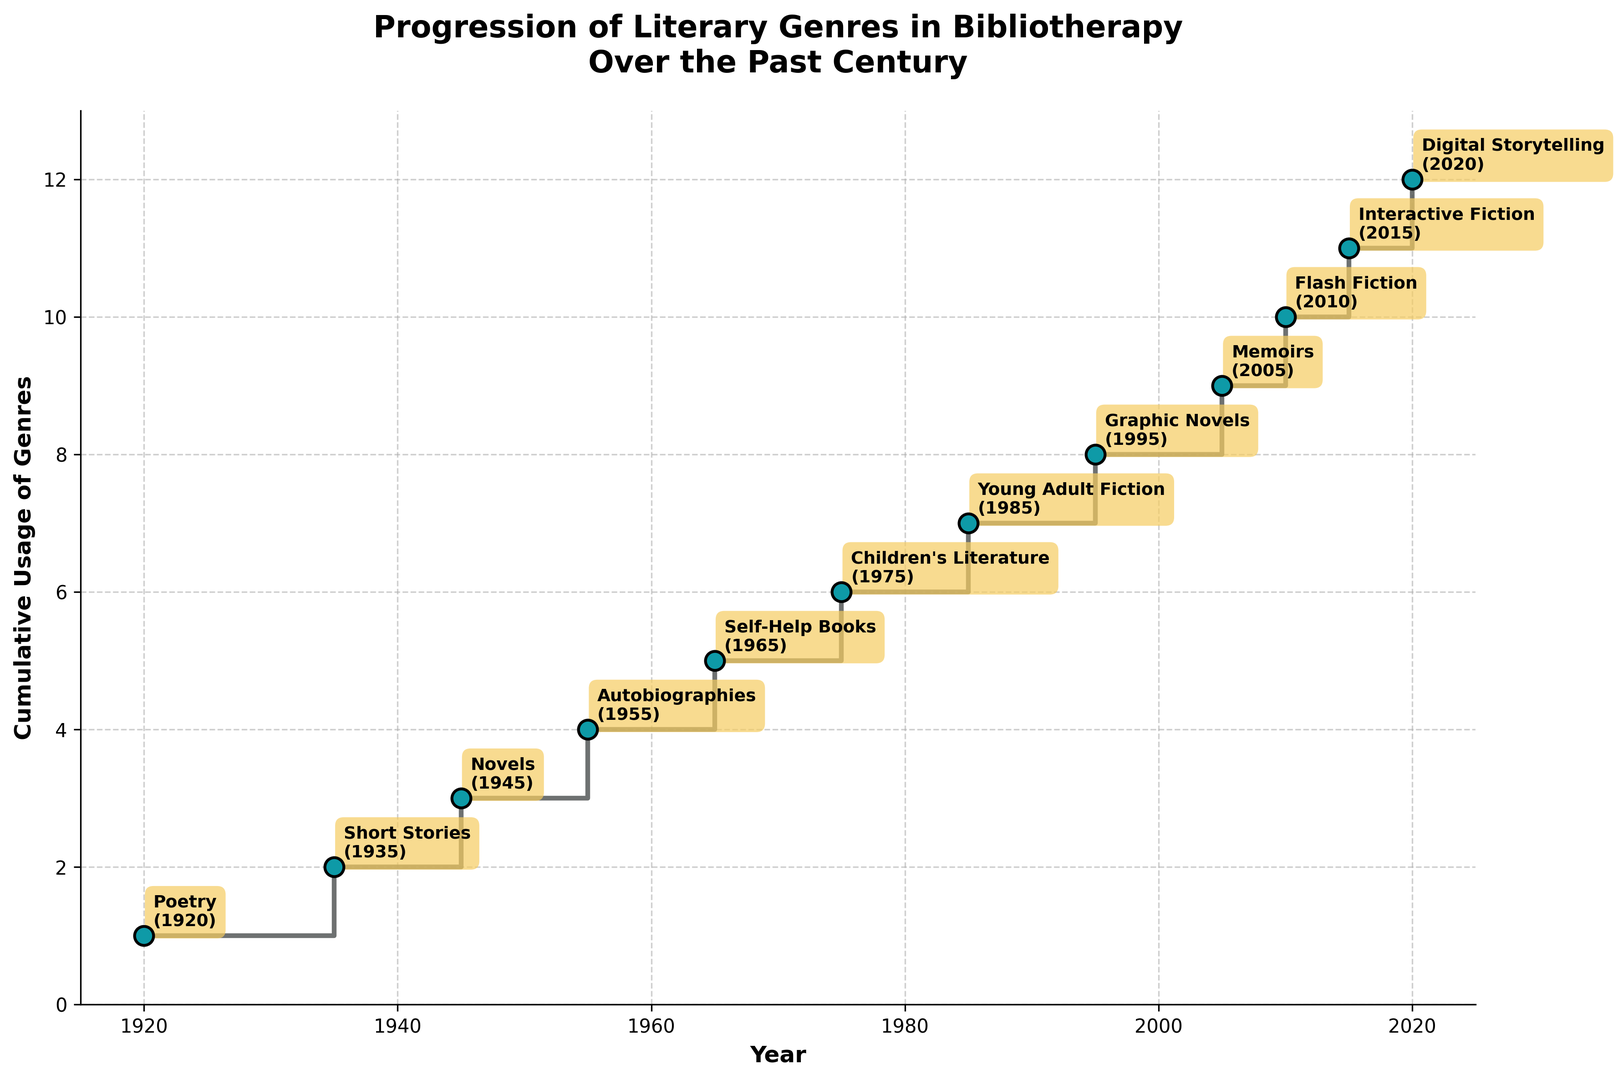How many literary genres had been integrated into bibliotherapy by the year 1975? To find the number of literary genres integrated into bibliotherapy by 1975, we need to count the cumulative usage values corresponding to the years less than or equal to 1975. According to the figure, these are: Poetry (1, 1920), Short Stories (2, 1935), Novels (3, 1945), Autobiographies (4, 1955), Self-Help Books (5, 1965), and Children's Literature (6, 1975). Thus, a total of 6 genres had been integrated by 1975.
Answer: 6 What is the difference in cumulative usage of genres between the years 2005 and 1985? To determine the difference in cumulative usage between 2005 and 1985, subtract the value for 1985 from the value for 2005. From the figure, the cumulative usage in 2005 is 9 (Memoirs) and in 1985 is 7 (Young Adult Fiction). Thus, the difference is 9 - 7 = 2.
Answer: 2 Which genre marked the 10th integration in bibliotherapy, and in which year did it happen? To find the 10th integrated genre, we need to look at the point corresponding to the cumulative usage of 10 in the figure. According to the plot, Flash Fiction was integrated when the cumulative usage hit 10, and this occurred in the year 2010.
Answer: Flash Fiction (2010) Comparing the cumulative usage in 1935 to that in 2020, how many more genres were integrated by 2020? To compare the cumulative usage between 1935 and 2020, examine the figure for both years. In 1935, the cumulative usage is 2 (Short Stories), and in 2020, it is 12 (Digital Storytelling). Therefore, the number of additional genres integrated by 2020 is 12 - 2 = 10.
Answer: 10 What visual changes occur in the plot when the bibliography reaches the year 1965? By looking from the starting point to 1965 on the plot, we see several visual changes: the step plot continues, reaching a cumulative usage of 5 with Self-Help Books. Visually, a step up is observed, and an annotation for "Self-Help Books" marks the year 1965.
Answer: Step up to 5 (Self-Help Books, 1965) Considering the genre additions between 2005 and 2020, how do their visual markers differ from earlier years? For genres added between 2005 (Memoirs) and 2020 (Digital Storytelling), the visual markers differ in their more modern and sophisticated terms. Earlier years involved more traditional genres like Poetry and Novels. The visual markers for the later years include annotations for innovative and contemporary genres like Flash Fiction, Interactive Fiction, and Digital Storytelling, reflecting the trend towards digital and interactive forms of literature.
Answer: Modern and digital genres What is the cumulative usage trend visually depicted in the plot from 1955 to 1975? Observing the period from 1955 (Autobiographies) to 1975 (Children's Literature) on the plot, the trend shows a steady increase in cumulative usage with each decade introducing a new genre (Self-Help Books in 1965 and Children's Literature in 1975). The escalation in the step plot indicates a consistent integration of genres into bibliotherapy over these years.
Answer: Steady increase How does the figure illustrate the diversification of literary genres used in bibliotherapy from 1920 to 2020? The figure uses a step plot with annotated points to illustrate the diversification of literary genres over time. Each step and annotation marks the introduction of a new genre, with intervals showing gradual integration from one genre (Poetry in 1920) to a wide variety including Digital Storytelling by 2020. This visual representation highlights both chronological evolution and genre diversity.
Answer: Step plot with annotations Which years showed the fastest growth in cumulative usage of literary genres? By analyzing the steps visually, the years to look at are those with the quickest vertical jumps indicating multiple genres being added in short periods. The year 1965 to 1975 and 2005 onwards, appear significant due to noticeable step increases. Specific years where marked growth is observed are from 2005 (Memoirs) with steady increments annually reaching 12 in 2020 (Digital Storytelling).
Answer: 2005 onwards 